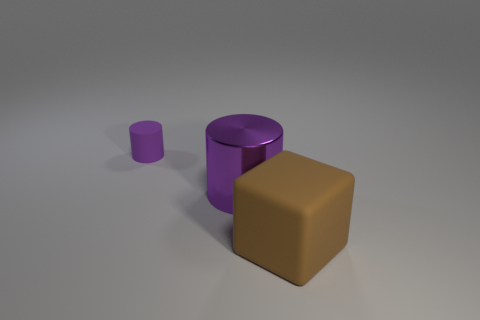There is a large thing that is behind the brown cube; what is its material?
Give a very brief answer. Metal. Does the large purple metallic object have the same shape as the rubber thing that is to the right of the small purple matte cylinder?
Provide a short and direct response. No. Is the number of small green metallic cubes greater than the number of large brown objects?
Your answer should be very brief. No. Are there any other things that are the same color as the large matte cube?
Offer a terse response. No. There is a tiny purple object that is made of the same material as the cube; what is its shape?
Your response must be concise. Cylinder. What is the big object that is right of the big thing that is behind the large brown cube made of?
Provide a short and direct response. Rubber. Do the purple object in front of the purple rubber cylinder and the brown matte thing have the same shape?
Give a very brief answer. No. Are there more big objects that are right of the tiny cylinder than green shiny cylinders?
Your response must be concise. Yes. Are there any other things that have the same material as the big purple cylinder?
Your answer should be compact. No. What shape is the big metal object that is the same color as the small rubber cylinder?
Offer a very short reply. Cylinder. 